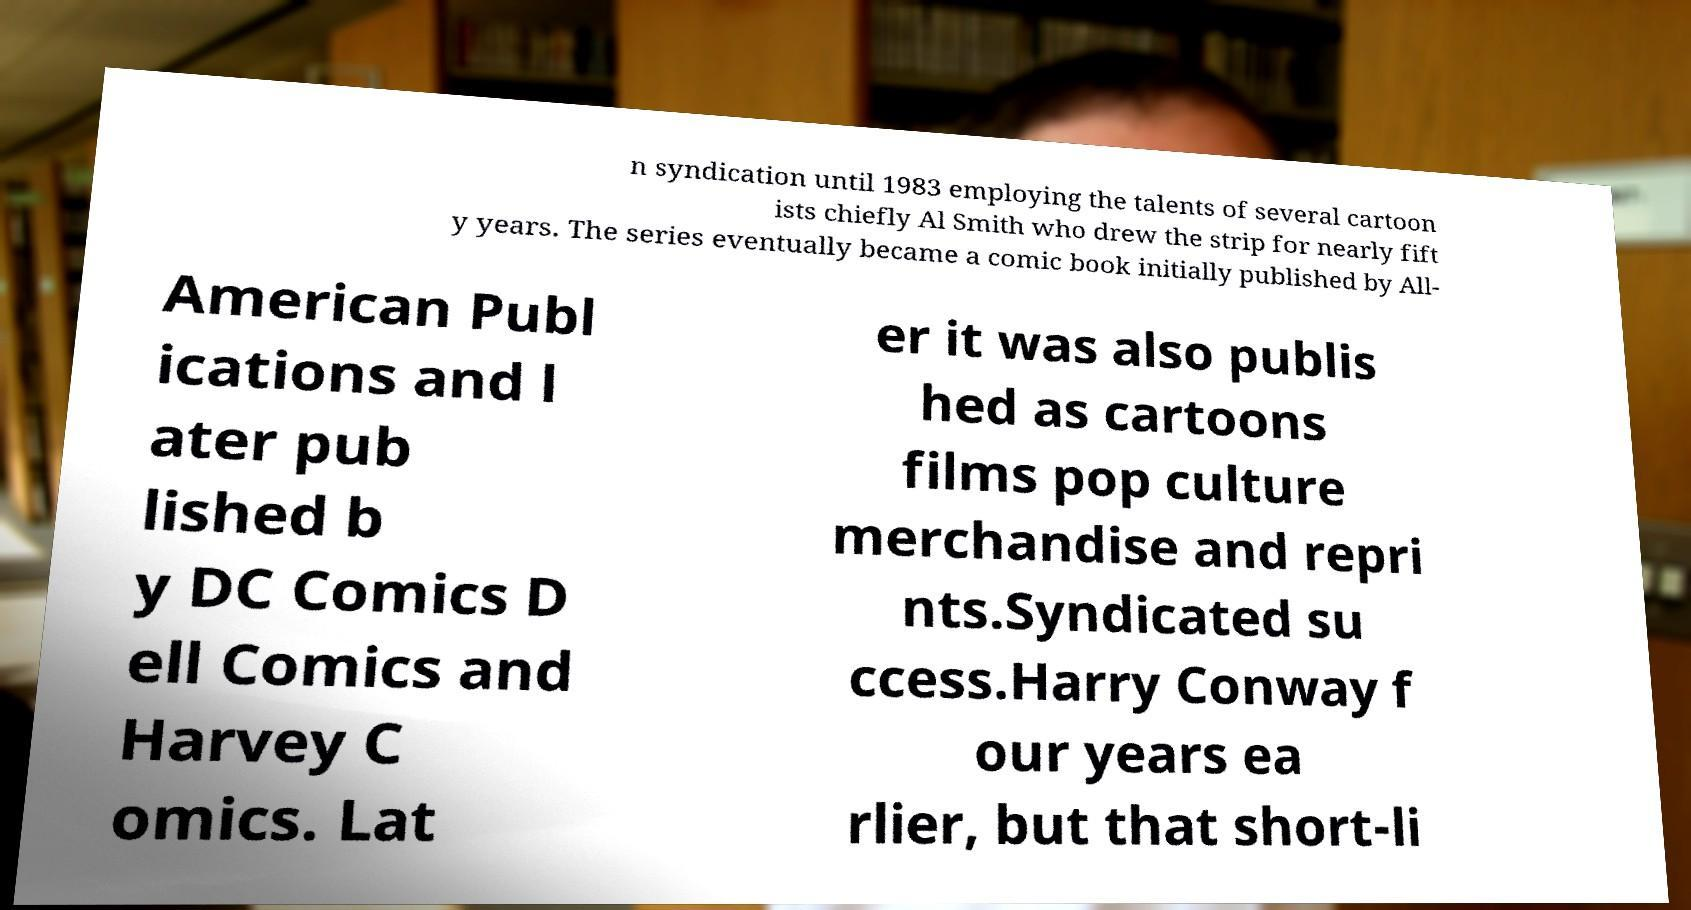I need the written content from this picture converted into text. Can you do that? n syndication until 1983 employing the talents of several cartoon ists chiefly Al Smith who drew the strip for nearly fift y years. The series eventually became a comic book initially published by All- American Publ ications and l ater pub lished b y DC Comics D ell Comics and Harvey C omics. Lat er it was also publis hed as cartoons films pop culture merchandise and repri nts.Syndicated su ccess.Harry Conway f our years ea rlier, but that short-li 